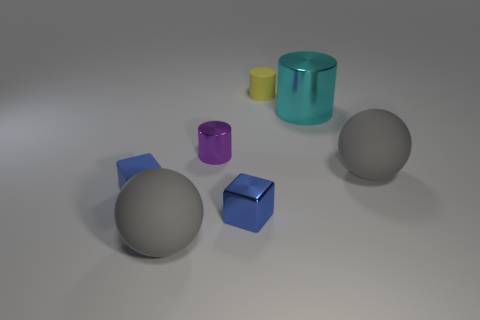Can you tell me the function of the round objects in this image? While this image is a rendering and not a depiction of real functional objects, the round objects resemble balls or spherical decor items, potentially serving an aesthetic purpose in this context. Do they have any specific textural properties that can be identified? Yes, the spherical objects have a smooth texture with soft shadows indicating a non-reflective, possibly matte or satin finish, which suggests they could be made of plastic or coated in a non-glossy paint. 